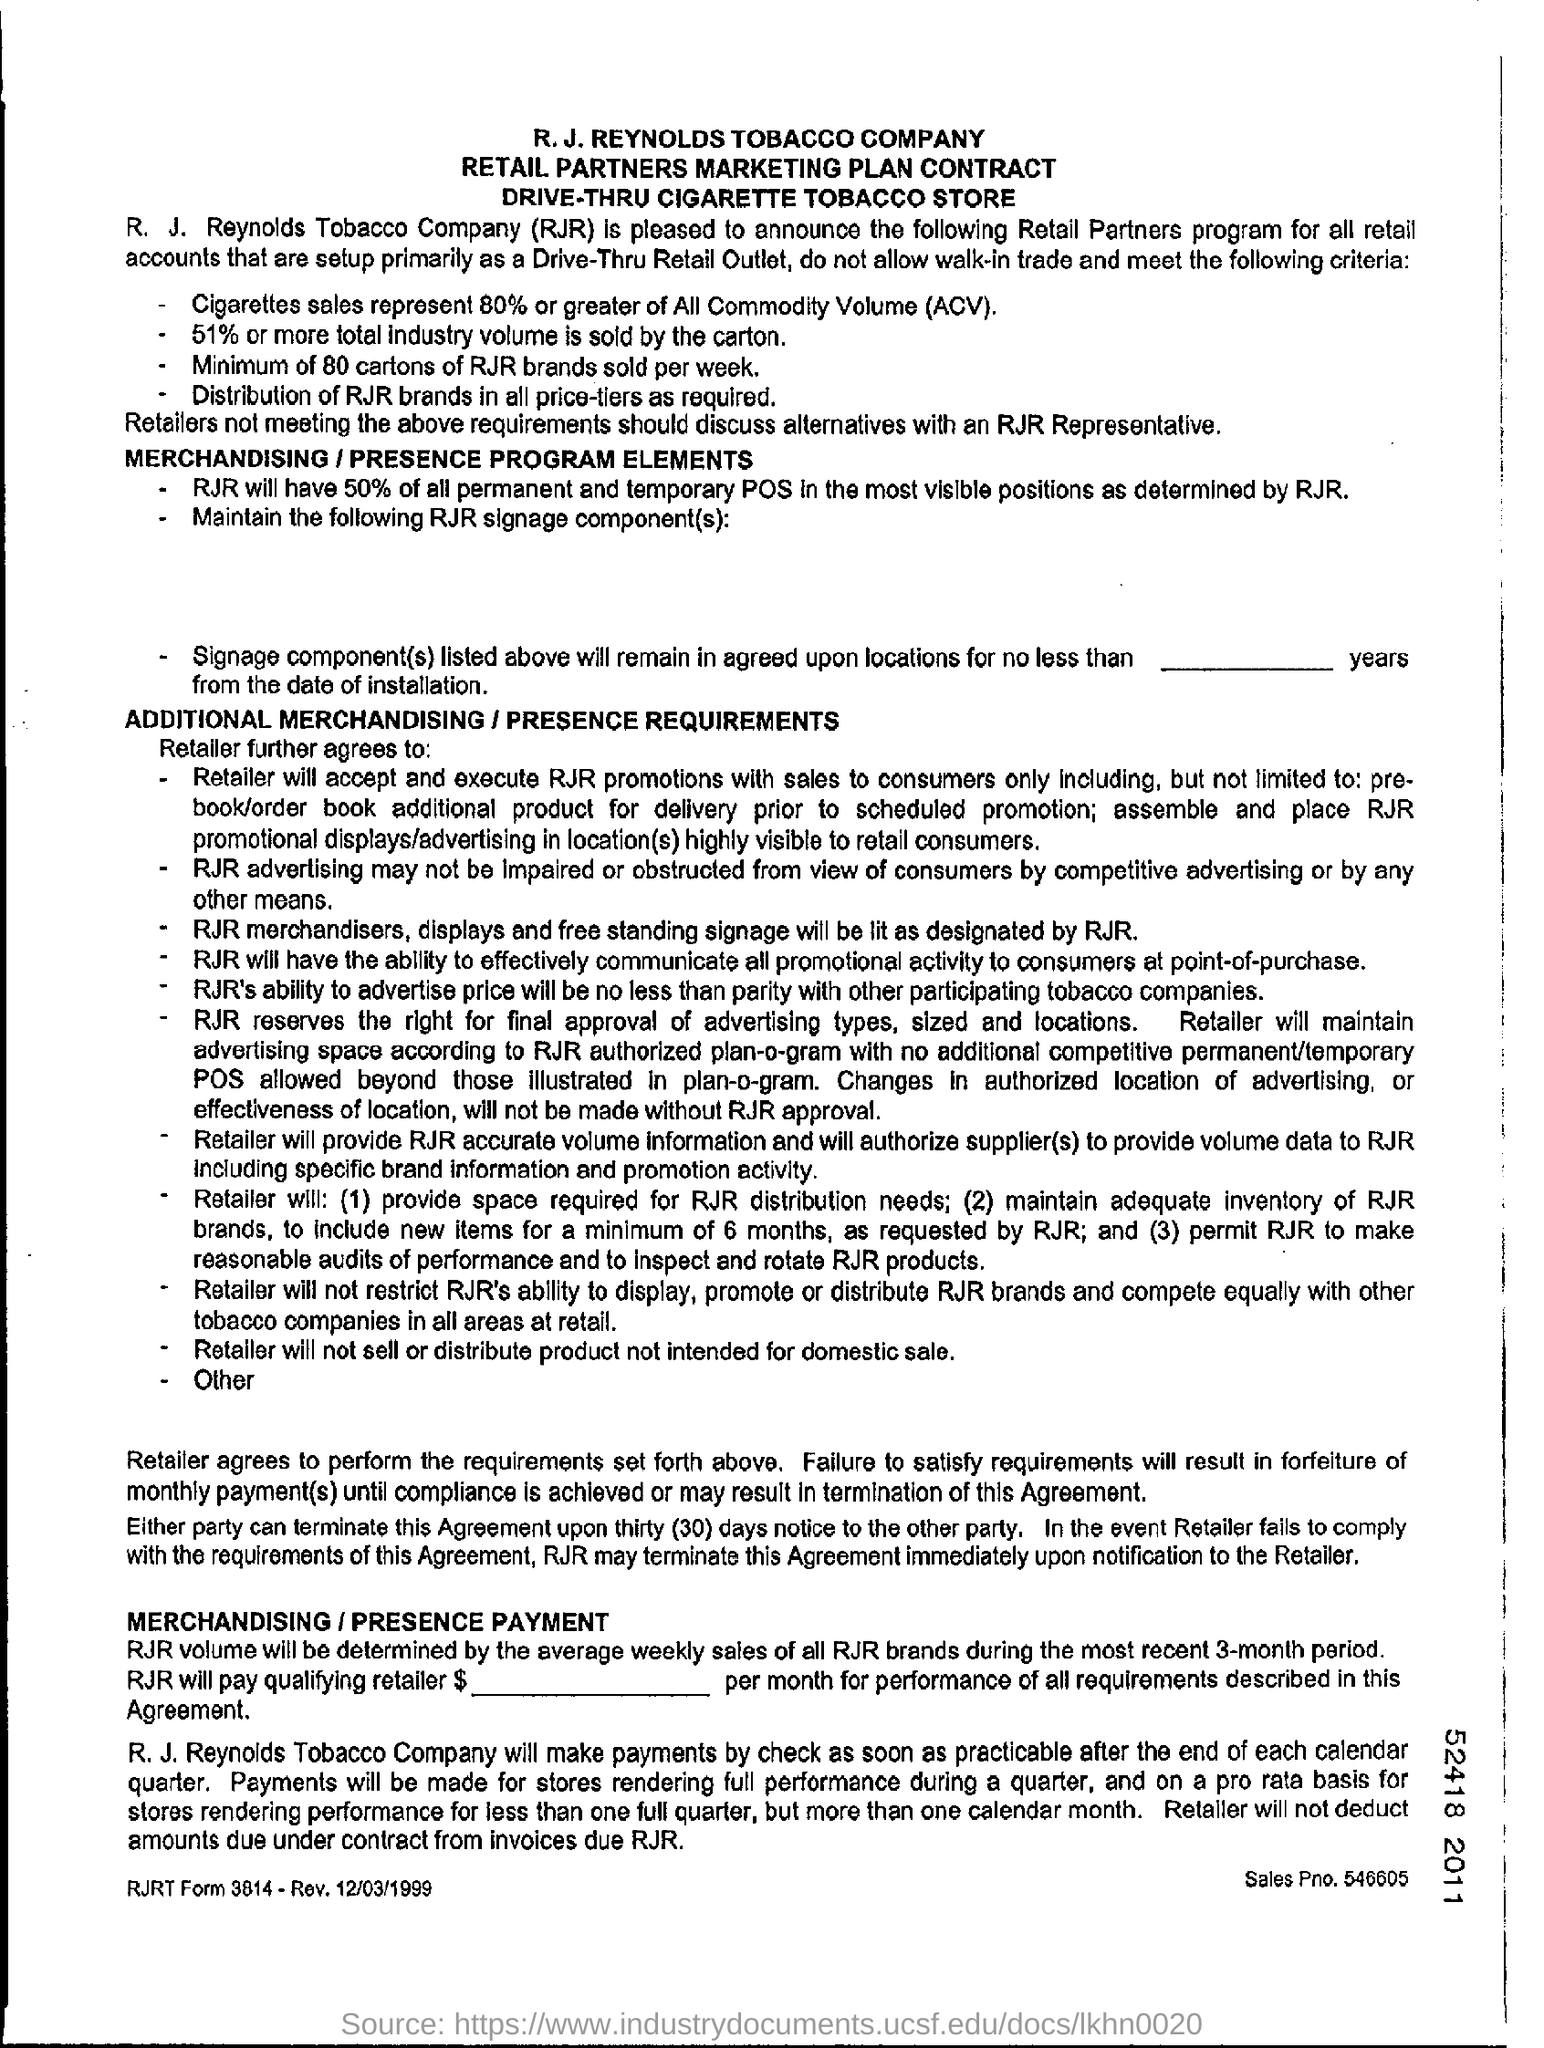What is the sales pno. ?
Your answer should be very brief. 546605. What is the full form of acv?
Provide a short and direct response. All commodity volume. What does rjr stands for ?
Offer a very short reply. R. J. Reynolds Tobacco Company. How much % will rjr have of all permanent and temporary pos in the most visible positions as determined by rjr ?
Your answer should be very brief. 50. What is the % or more of total industry volume is sold by the carton ?
Ensure brevity in your answer.  51. 